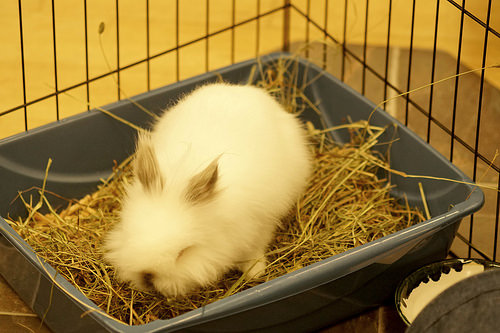<image>
Is there a rabbit on the plastic bowl? Yes. Looking at the image, I can see the rabbit is positioned on top of the plastic bowl, with the plastic bowl providing support. Where is the bunny in relation to the straw? Is it next to the straw? Yes. The bunny is positioned adjacent to the straw, located nearby in the same general area. 